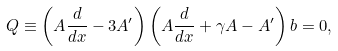Convert formula to latex. <formula><loc_0><loc_0><loc_500><loc_500>Q \equiv \left ( A \frac { d } { d x } - 3 A ^ { \prime } \right ) \left ( A \frac { d } { d x } + \gamma A - A ^ { \prime } \right ) b = 0 ,</formula> 